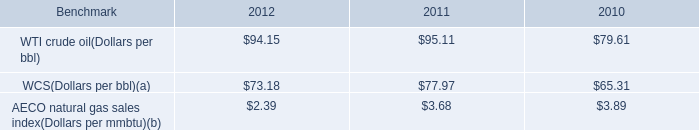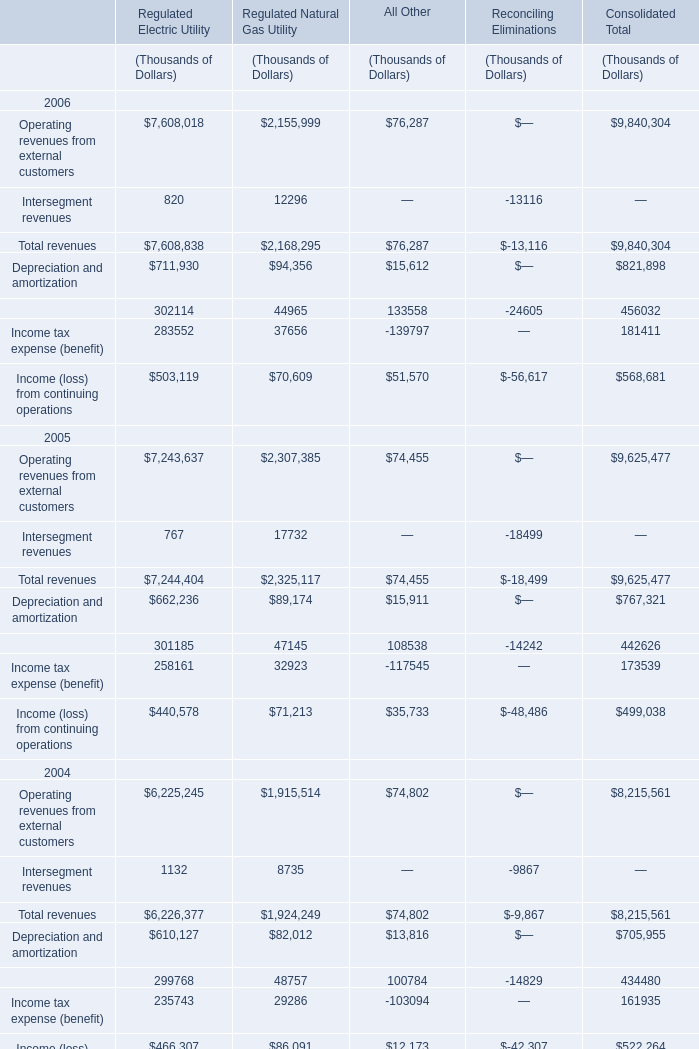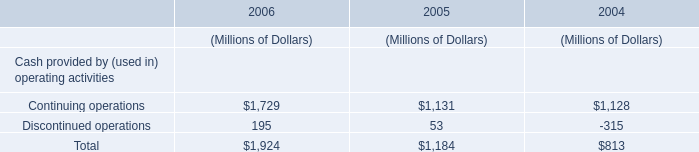by what percentage did the average price per barrel of wcs increase from 2010 to 2012? 
Computations: ((73.18 - 65.31) / 65.31)
Answer: 0.1205. What is the growing rate of Total revenues in the years with the least Operating revenues from external customers? 
Computations: ((9625477 - 8215561) / 8215561)
Answer: 0.17162. 